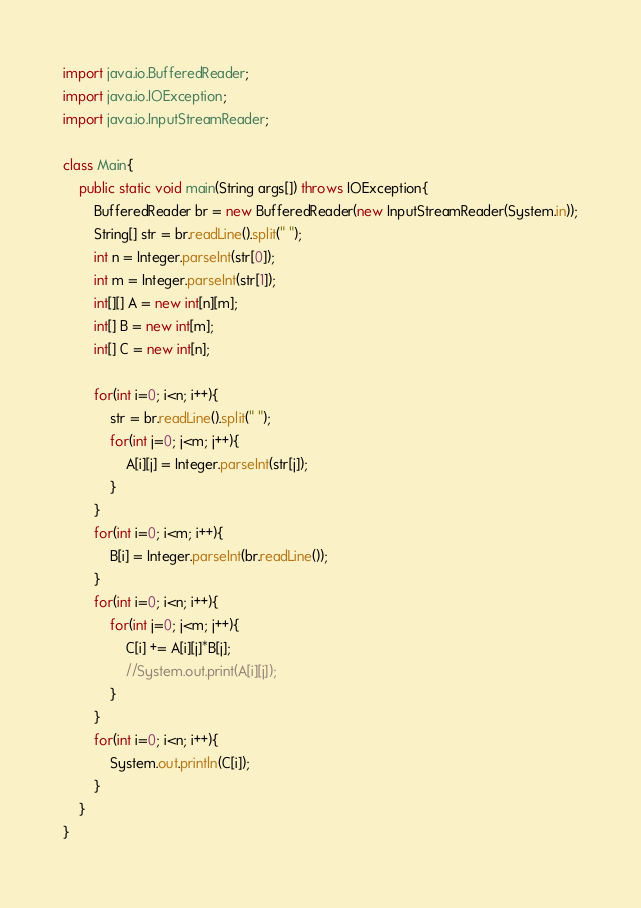Convert code to text. <code><loc_0><loc_0><loc_500><loc_500><_Java_>
import java.io.BufferedReader;
import java.io.IOException;
import java.io.InputStreamReader;

class Main{
	public static void main(String args[]) throws IOException{
		BufferedReader br = new BufferedReader(new InputStreamReader(System.in));
		String[] str = br.readLine().split(" ");
		int n = Integer.parseInt(str[0]);
		int m = Integer.parseInt(str[1]);
		int[][] A = new int[n][m];
		int[] B = new int[m];
		int[] C = new int[n];

		for(int i=0; i<n; i++){
			str = br.readLine().split(" ");
			for(int j=0; j<m; j++){
				A[i][j] = Integer.parseInt(str[j]);
			}
		}
		for(int i=0; i<m; i++){
			B[i] = Integer.parseInt(br.readLine());
		}
		for(int i=0; i<n; i++){
			for(int j=0; j<m; j++){
				C[i] += A[i][j]*B[j];
				//System.out.print(A[i][j]);
			}
		}
		for(int i=0; i<n; i++){
			System.out.println(C[i]);
		}
	}
}</code> 